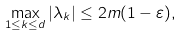<formula> <loc_0><loc_0><loc_500><loc_500>\max _ { 1 \leq k \leq d } | \lambda _ { k } | \leq 2 m ( 1 - \varepsilon ) ,</formula> 